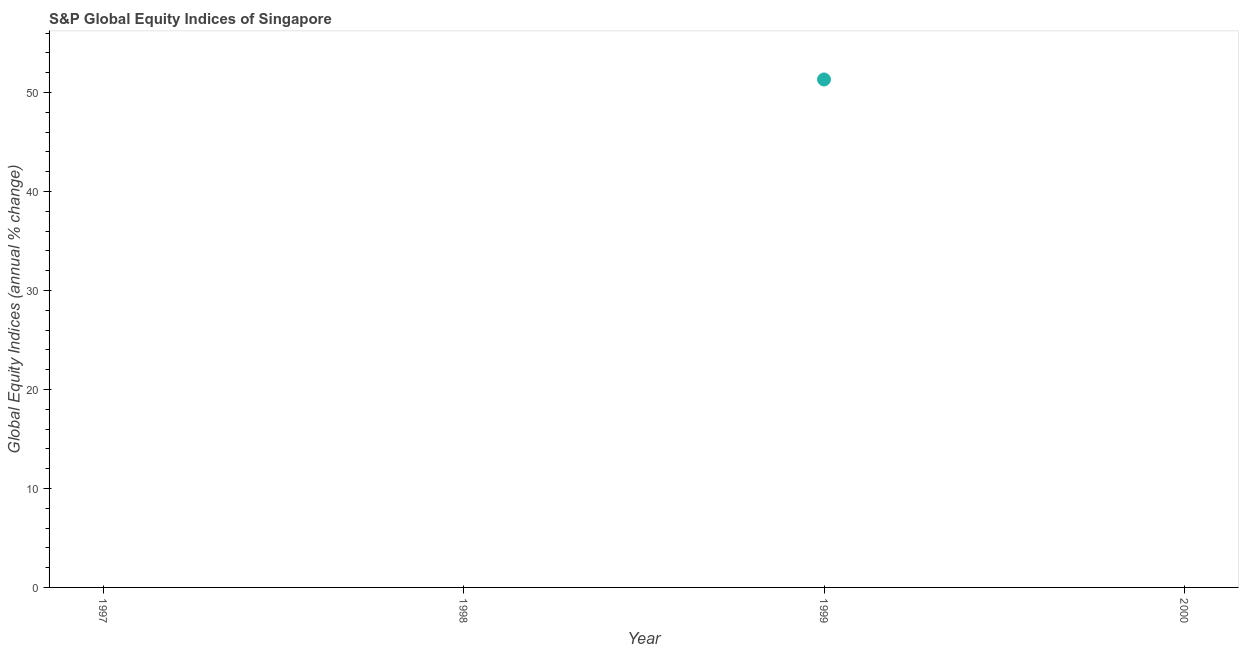What is the s&p global equity indices in 1997?
Your answer should be very brief. 0. Across all years, what is the maximum s&p global equity indices?
Offer a terse response. 51.32. Across all years, what is the minimum s&p global equity indices?
Offer a very short reply. 0. What is the sum of the s&p global equity indices?
Provide a short and direct response. 51.32. What is the average s&p global equity indices per year?
Ensure brevity in your answer.  12.83. In how many years, is the s&p global equity indices greater than 28 %?
Your response must be concise. 1. What is the difference between the highest and the lowest s&p global equity indices?
Make the answer very short. 51.32. How many dotlines are there?
Provide a succinct answer. 1. How many years are there in the graph?
Your answer should be compact. 4. Are the values on the major ticks of Y-axis written in scientific E-notation?
Keep it short and to the point. No. What is the title of the graph?
Your response must be concise. S&P Global Equity Indices of Singapore. What is the label or title of the X-axis?
Give a very brief answer. Year. What is the label or title of the Y-axis?
Offer a very short reply. Global Equity Indices (annual % change). What is the Global Equity Indices (annual % change) in 1998?
Your answer should be compact. 0. What is the Global Equity Indices (annual % change) in 1999?
Keep it short and to the point. 51.32. What is the Global Equity Indices (annual % change) in 2000?
Give a very brief answer. 0. 